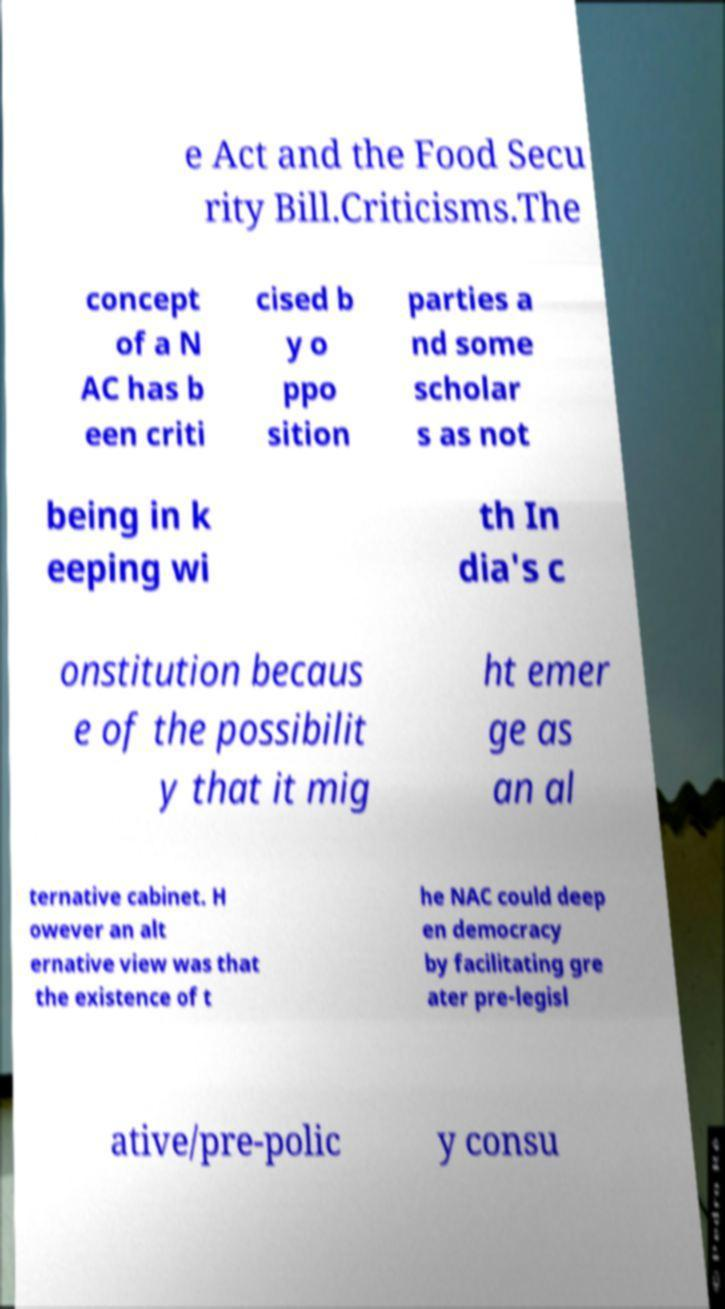Please read and relay the text visible in this image. What does it say? e Act and the Food Secu rity Bill.Criticisms.The concept of a N AC has b een criti cised b y o ppo sition parties a nd some scholar s as not being in k eeping wi th In dia's c onstitution becaus e of the possibilit y that it mig ht emer ge as an al ternative cabinet. H owever an alt ernative view was that the existence of t he NAC could deep en democracy by facilitating gre ater pre-legisl ative/pre-polic y consu 